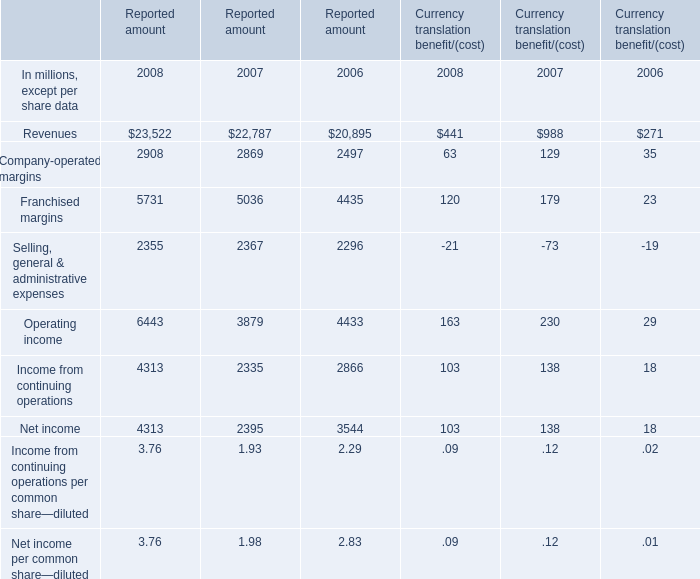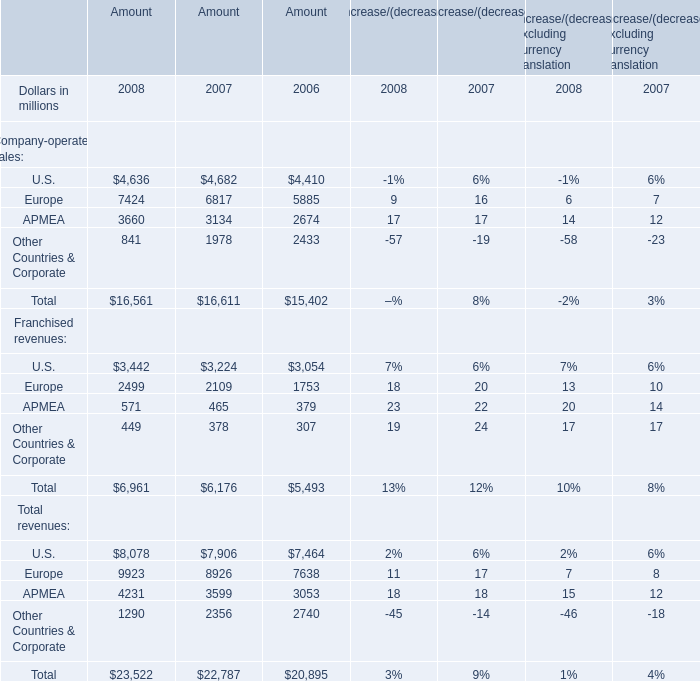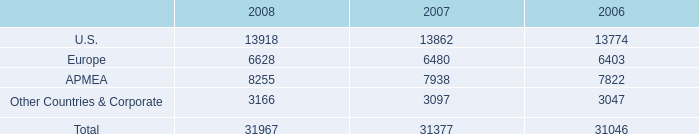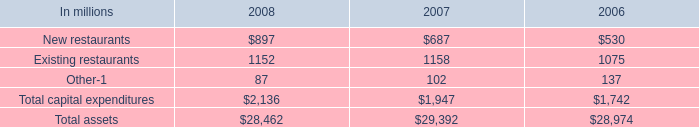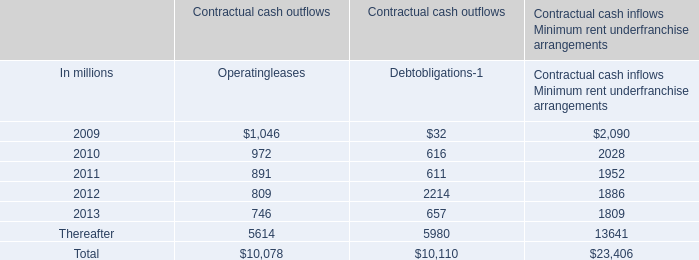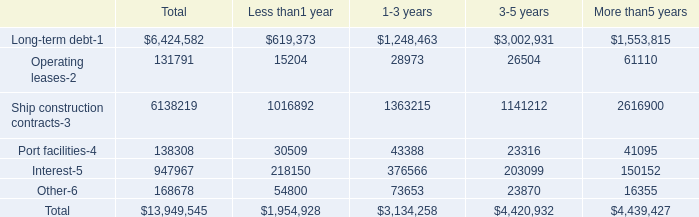What was the average value of Company-operated margins, Franchised margins, Selling, general & administrative expenses in 2008 for Reported amount? (in million) 
Computations: (((2908 + 5731) + 2355) / 3)
Answer: 3664.66667. 